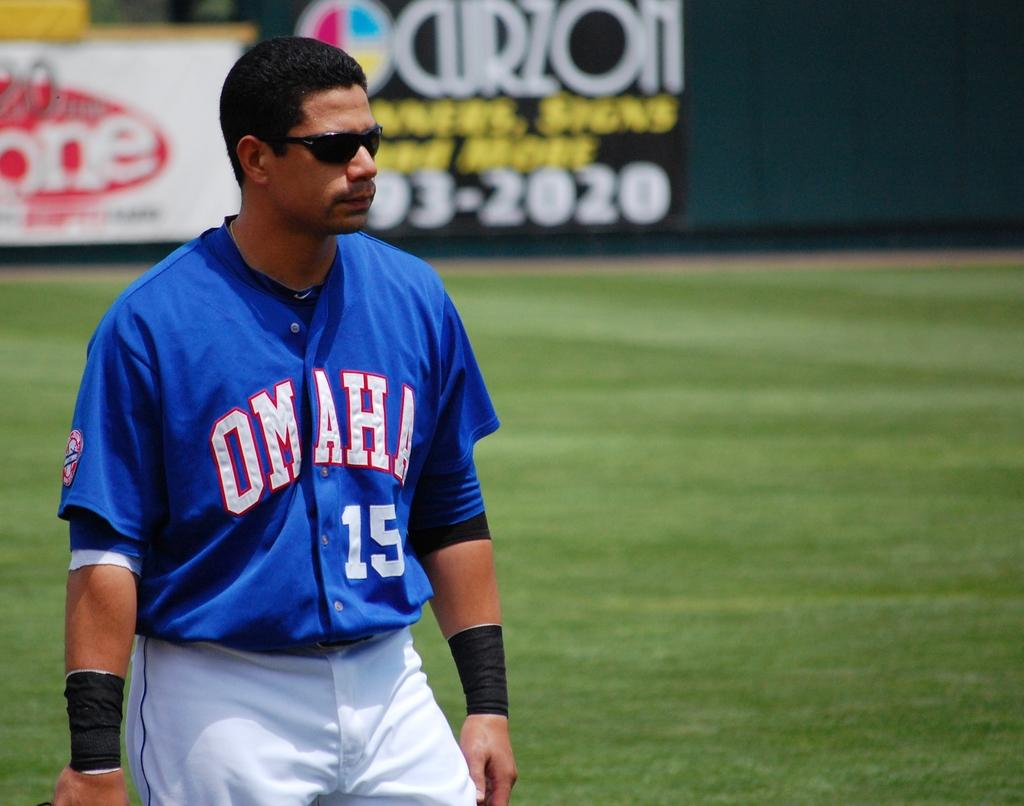<image>
Offer a succinct explanation of the picture presented. The baseball player 15, from Omaha is walking on to the field wearing dark sunglasses. 